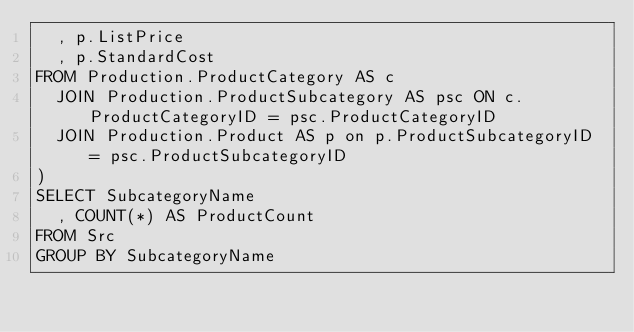<code> <loc_0><loc_0><loc_500><loc_500><_SQL_>  , p.ListPrice
  , p.StandardCost
FROM Production.ProductCategory AS c
  JOIN Production.ProductSubcategory AS psc ON c.ProductCategoryID = psc.ProductCategoryID
  JOIN Production.Product AS p on p.ProductSubcategoryID = psc.ProductSubcategoryID
)
SELECT SubcategoryName
  , COUNT(*) AS ProductCount
FROM Src
GROUP BY SubcategoryName</code> 